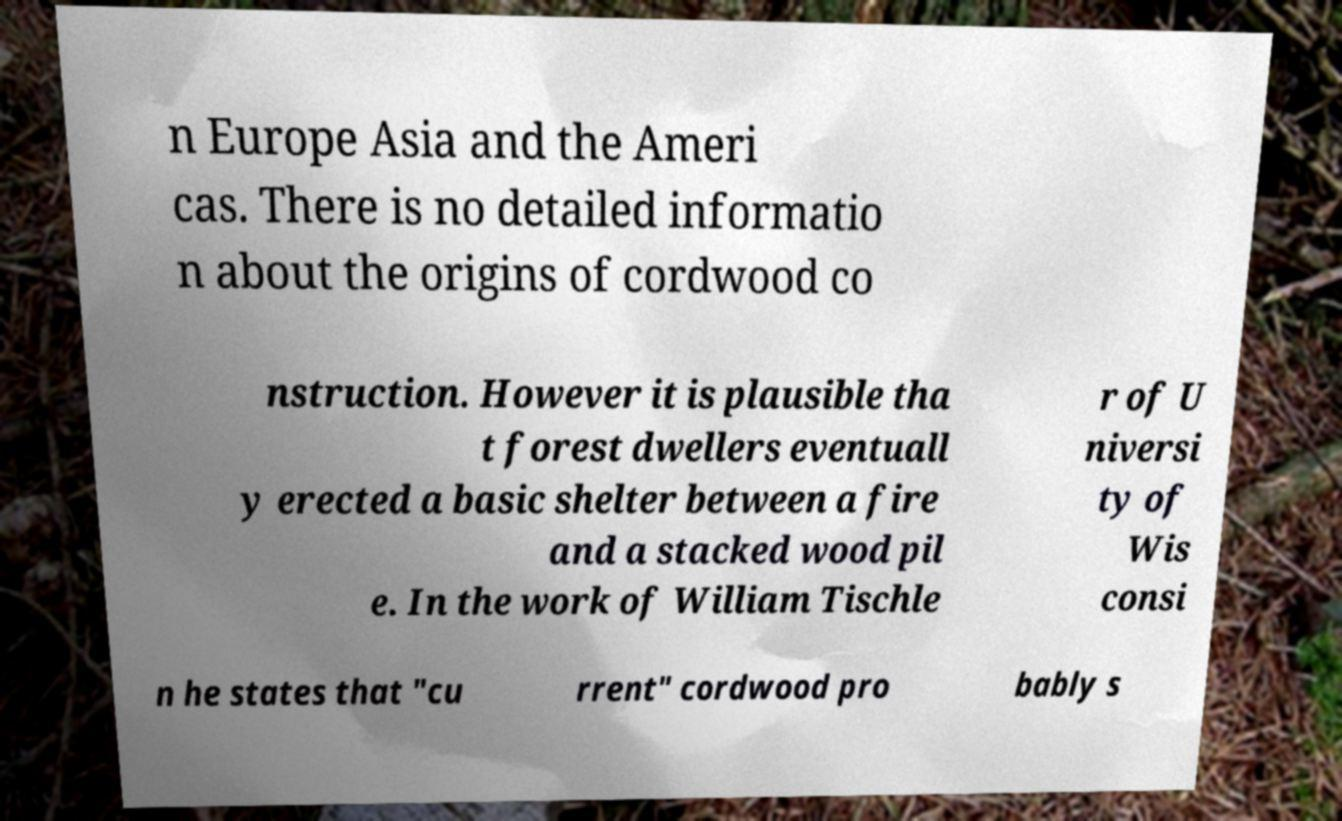For documentation purposes, I need the text within this image transcribed. Could you provide that? n Europe Asia and the Ameri cas. There is no detailed informatio n about the origins of cordwood co nstruction. However it is plausible tha t forest dwellers eventuall y erected a basic shelter between a fire and a stacked wood pil e. In the work of William Tischle r of U niversi ty of Wis consi n he states that "cu rrent" cordwood pro bably s 